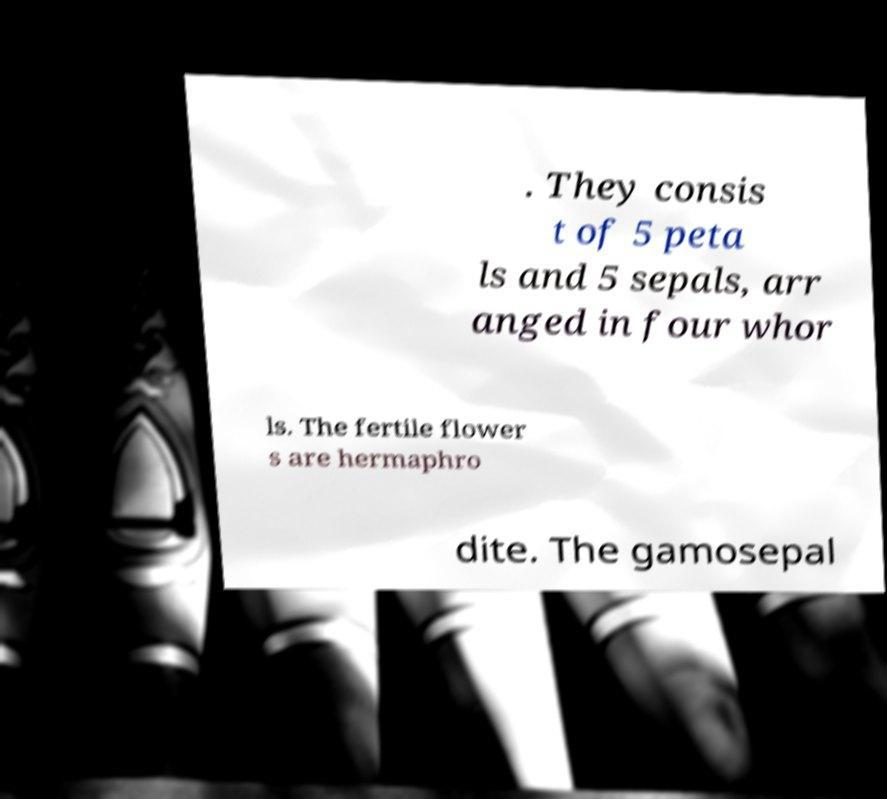For documentation purposes, I need the text within this image transcribed. Could you provide that? . They consis t of 5 peta ls and 5 sepals, arr anged in four whor ls. The fertile flower s are hermaphro dite. The gamosepal 